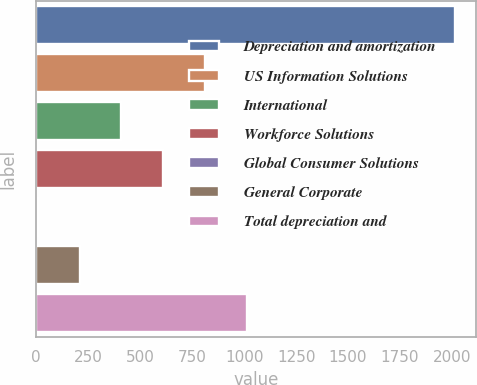Convert chart. <chart><loc_0><loc_0><loc_500><loc_500><bar_chart><fcel>Depreciation and amortization<fcel>US Information Solutions<fcel>International<fcel>Workforce Solutions<fcel>Global Consumer Solutions<fcel>General Corporate<fcel>Total depreciation and<nl><fcel>2015<fcel>811.64<fcel>410.52<fcel>611.08<fcel>9.4<fcel>209.96<fcel>1012.2<nl></chart> 